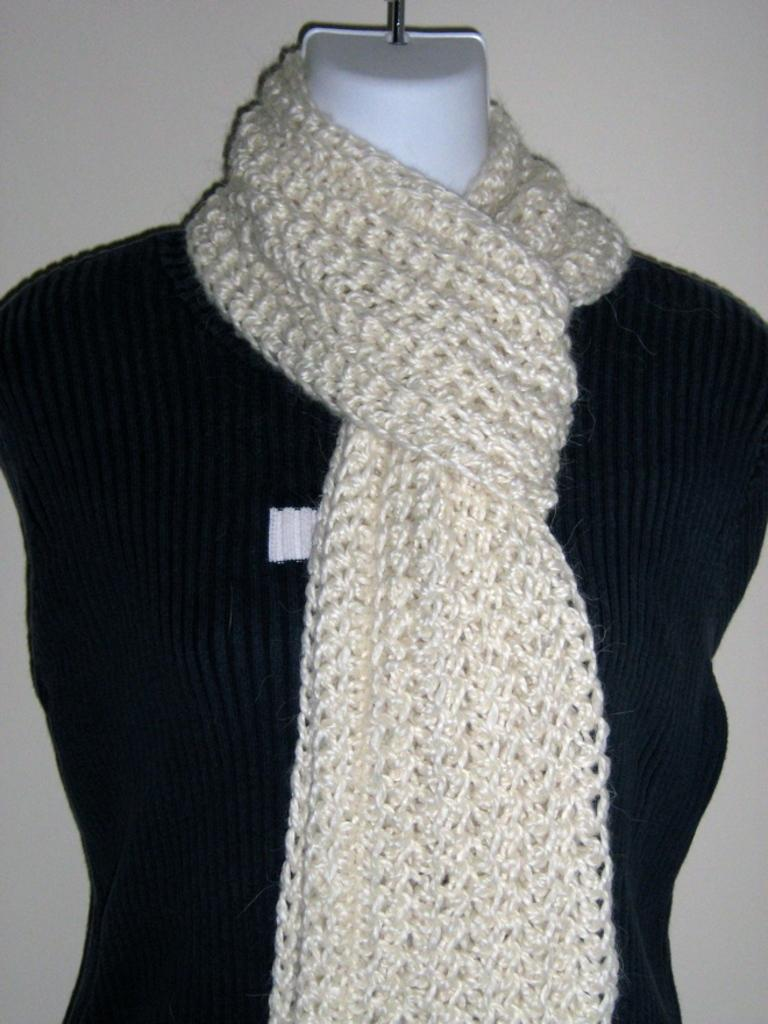What is the main subject in the image? There is a mannequin in the image. What type of clothing is the mannequin wearing? The mannequin is wearing a sweater. Are there any accessories visible on the mannequin? Yes, the mannequin is also wearing a stole. Can you tell me how the mannequin is helping someone in the image? The mannequin is not a living being and therefore cannot help someone in the image. 